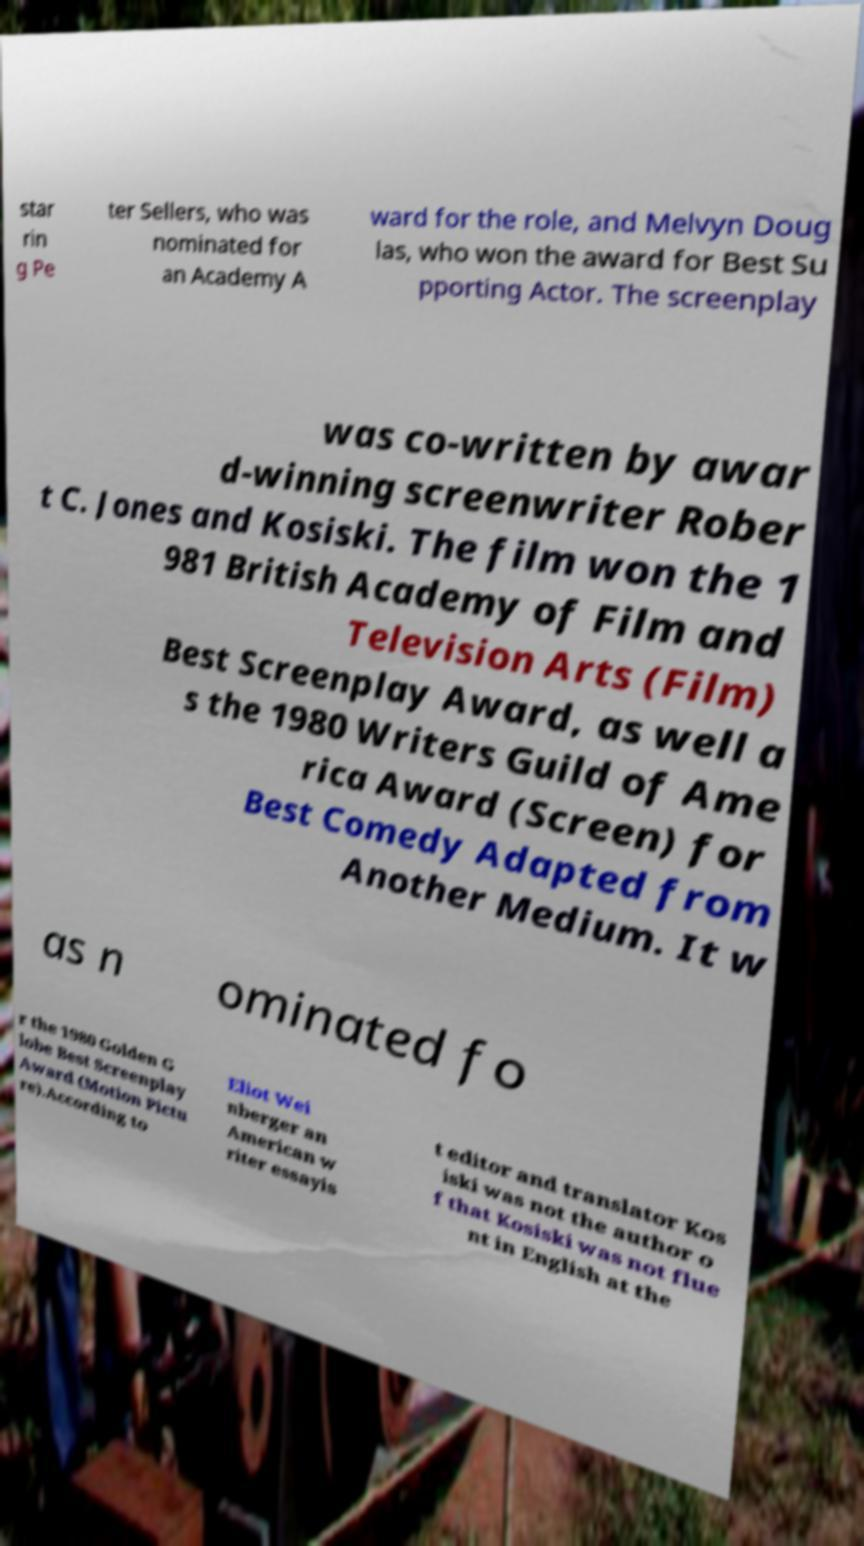Could you extract and type out the text from this image? star rin g Pe ter Sellers, who was nominated for an Academy A ward for the role, and Melvyn Doug las, who won the award for Best Su pporting Actor. The screenplay was co-written by awar d-winning screenwriter Rober t C. Jones and Kosiski. The film won the 1 981 British Academy of Film and Television Arts (Film) Best Screenplay Award, as well a s the 1980 Writers Guild of Ame rica Award (Screen) for Best Comedy Adapted from Another Medium. It w as n ominated fo r the 1980 Golden G lobe Best Screenplay Award (Motion Pictu re).According to Eliot Wei nberger an American w riter essayis t editor and translator Kos iski was not the author o f that Kosiski was not flue nt in English at the 